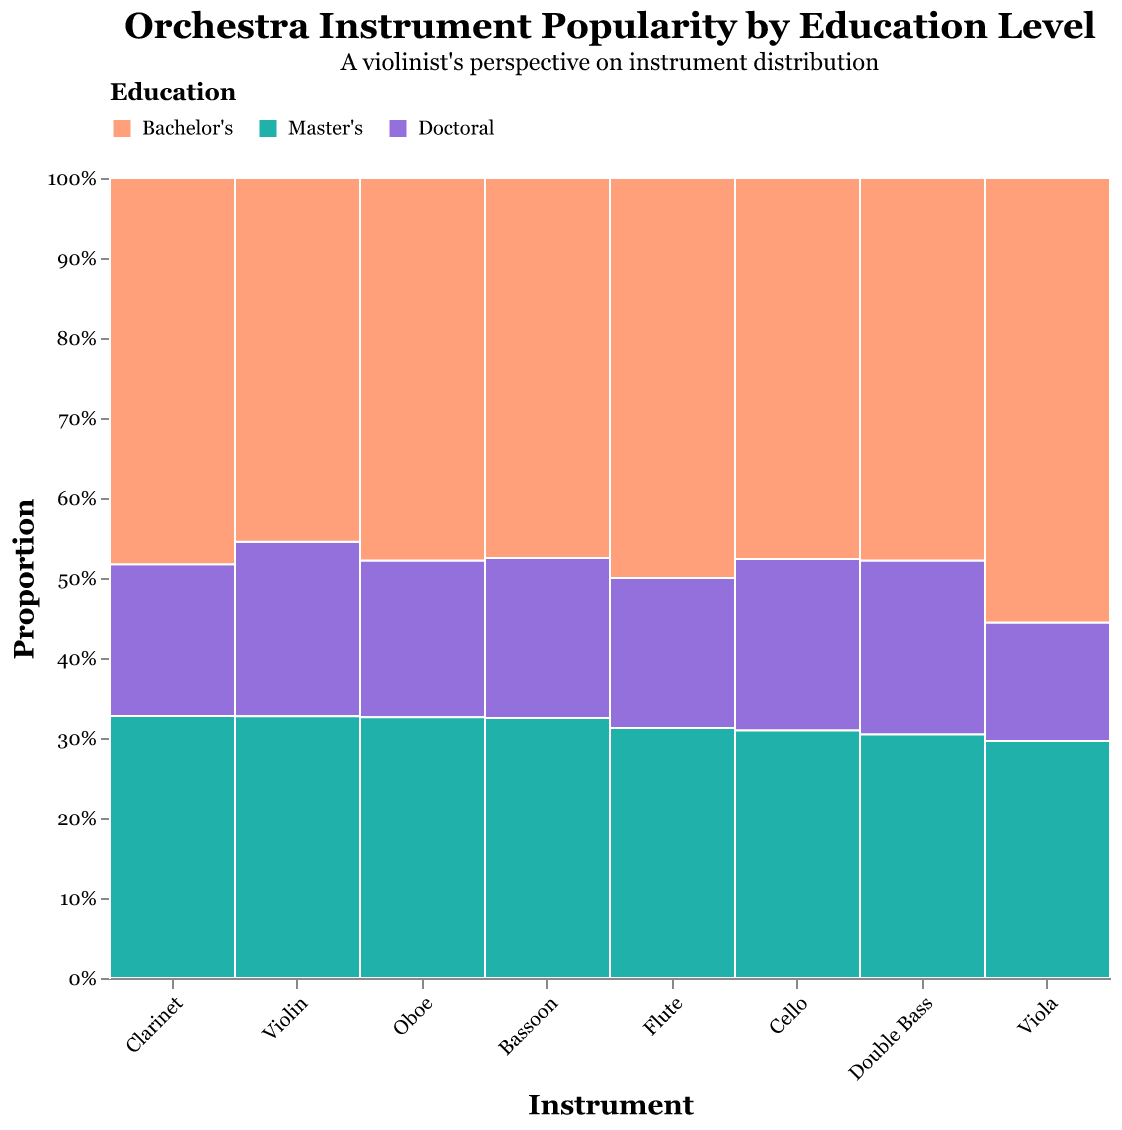What is the most common education level among professional violinists? Look for the Violin section in the plot and observe which education level has the largest proportion. The Bachelor's level has the largest area in the Violin segment.
Answer: Bachelor's How does the distribution of education levels among violists compare to that among violinists? Compare the relative sizes of the different education levels for both Violin and Viola. For Violin, the proportion of Bachelor's is largest, followed by Master's, then Doctoral. For Viola, the Bachelor's proportion is largest, but the proportions of Master's and Doctoral are much smaller compared to those of Violin.
Answer: Violinists have higher proportions of Master's and Doctoral degrees compared to violists Which instrument has the highest proportion of Master's degree holders? Look at the plot and compare the areas of the Master's sections for each instrument. The Violin section has the largest Master's proportion.
Answer: Violin What percentage of professional violinists hold a Doctoral degree? Hover over the Doctoral section within the Violin part of the plot to see the tooltip. The percentage displayed there is 17.7%.
Answer: 17.7% Which woodwind instrument has the lowest number of Bachelor's degree holders? Compare the Bachelor's sections among the woodwind instruments (Flute, Clarinet, Oboe, Bassoon) and identify the smallest area. The Bassoon has the smallest Bachelor's section.
Answer: Bassoon What is the total count of professional musicians with a Master's degree in the dataset? Sum the counts for Master's degrees across all instruments: 180 (Violin) + 80 (Viola) + 130 (Cello) + 70 (Double Bass) + 100 (Flute) + 95 (Clarinet) + 75 (Oboe) + 65 (Bassoon).
Answer: 795 Compare the proportion of Bachelor's degree holders between Cellists and Double Bass players. Observe the Bachelor's sections for Cello and Double Bass, Cellists have a larger proportion (largest area) compared to Double Bass players.
Answer: Cellists have a higher proportion than Double Bass players How many more professional violinists hold a Bachelor's degree compared to violists? Subtract the Bachelor's count of Viola from Violin: 250 (Violin) - 150 (Viola).
Answer: 100 Is the proportion of Doctoral degree holders higher among bassoon players or oboists? Compare the areas of Doctoral sections in the Bassoon and Oboe parts of the plot. Both areas are similar, but Oboe has a slightly larger Doctoral section.
Answer: Oboe What is the least common education level among Double Bass players? Look at the Double Bass section and identify the smallest proportion, which is Master's.
Answer: Master's 